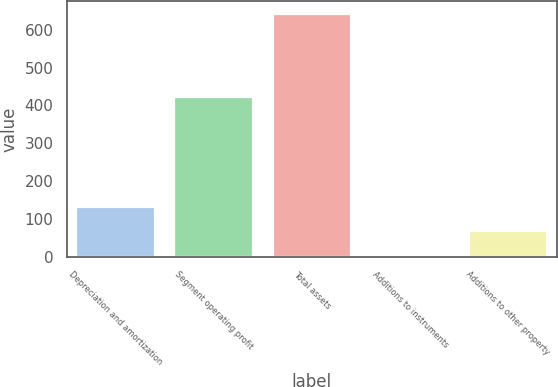<chart> <loc_0><loc_0><loc_500><loc_500><bar_chart><fcel>Depreciation and amortization<fcel>Segment operating profit<fcel>Total assets<fcel>Additions to instruments<fcel>Additions to other property<nl><fcel>132.24<fcel>421.9<fcel>642.4<fcel>4.7<fcel>68.47<nl></chart> 